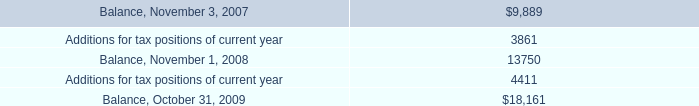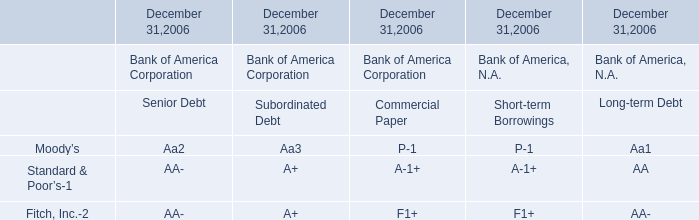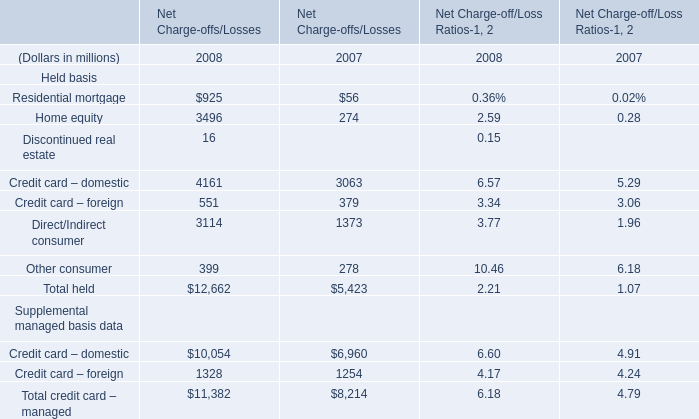If Home equity of Net Charge-offs/Losses develops with the same increasing rate in 2008, what will it reach in 2009? (in million) 
Computations: (3496 * (1 + ((3496 - 274) / 274)))
Answer: 44605.89781. 